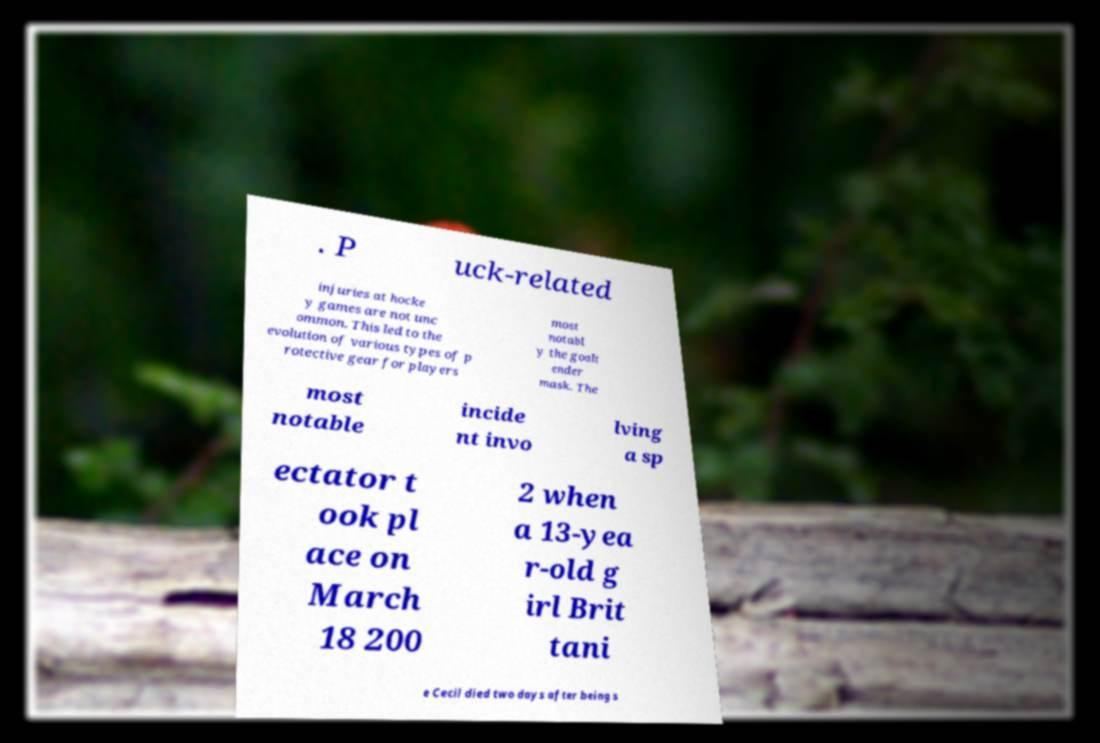Please identify and transcribe the text found in this image. . P uck-related injuries at hocke y games are not unc ommon. This led to the evolution of various types of p rotective gear for players most notabl y the goalt ender mask. The most notable incide nt invo lving a sp ectator t ook pl ace on March 18 200 2 when a 13-yea r-old g irl Brit tani e Cecil died two days after being s 